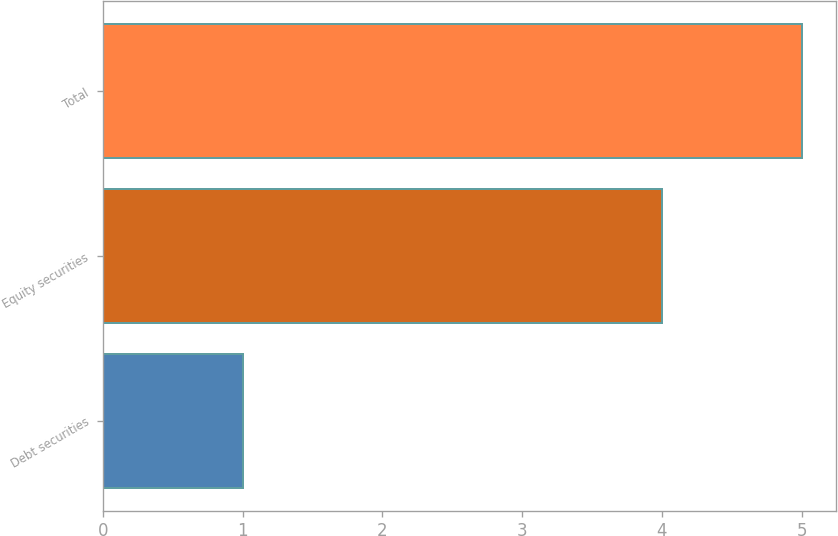Convert chart to OTSL. <chart><loc_0><loc_0><loc_500><loc_500><bar_chart><fcel>Debt securities<fcel>Equity securities<fcel>Total<nl><fcel>1<fcel>4<fcel>5<nl></chart> 